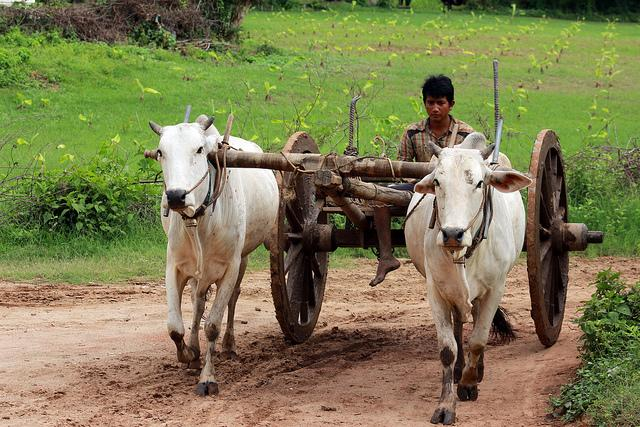What is behind the animals? cart 